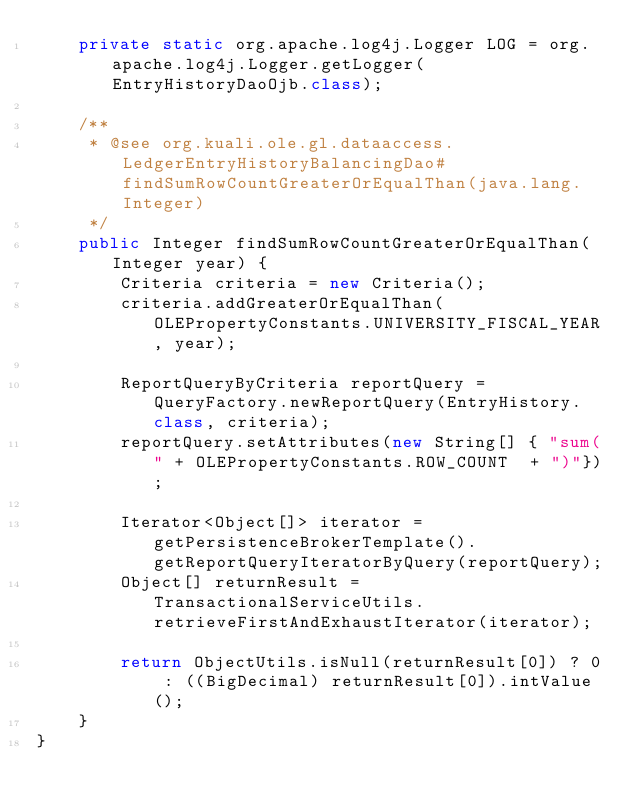Convert code to text. <code><loc_0><loc_0><loc_500><loc_500><_Java_>    private static org.apache.log4j.Logger LOG = org.apache.log4j.Logger.getLogger(EntryHistoryDaoOjb.class);
    
    /**
     * @see org.kuali.ole.gl.dataaccess.LedgerEntryHistoryBalancingDao#findSumRowCountGreaterOrEqualThan(java.lang.Integer)
     */
    public Integer findSumRowCountGreaterOrEqualThan(Integer year) {
        Criteria criteria = new Criteria();
        criteria.addGreaterOrEqualThan(OLEPropertyConstants.UNIVERSITY_FISCAL_YEAR, year);
        
        ReportQueryByCriteria reportQuery = QueryFactory.newReportQuery(EntryHistory.class, criteria);
        reportQuery.setAttributes(new String[] { "sum(" + OLEPropertyConstants.ROW_COUNT  + ")"});
        
        Iterator<Object[]> iterator = getPersistenceBrokerTemplate().getReportQueryIteratorByQuery(reportQuery);
        Object[] returnResult = TransactionalServiceUtils.retrieveFirstAndExhaustIterator(iterator);
        
        return ObjectUtils.isNull(returnResult[0]) ? 0 : ((BigDecimal) returnResult[0]).intValue();
    }
}
</code> 